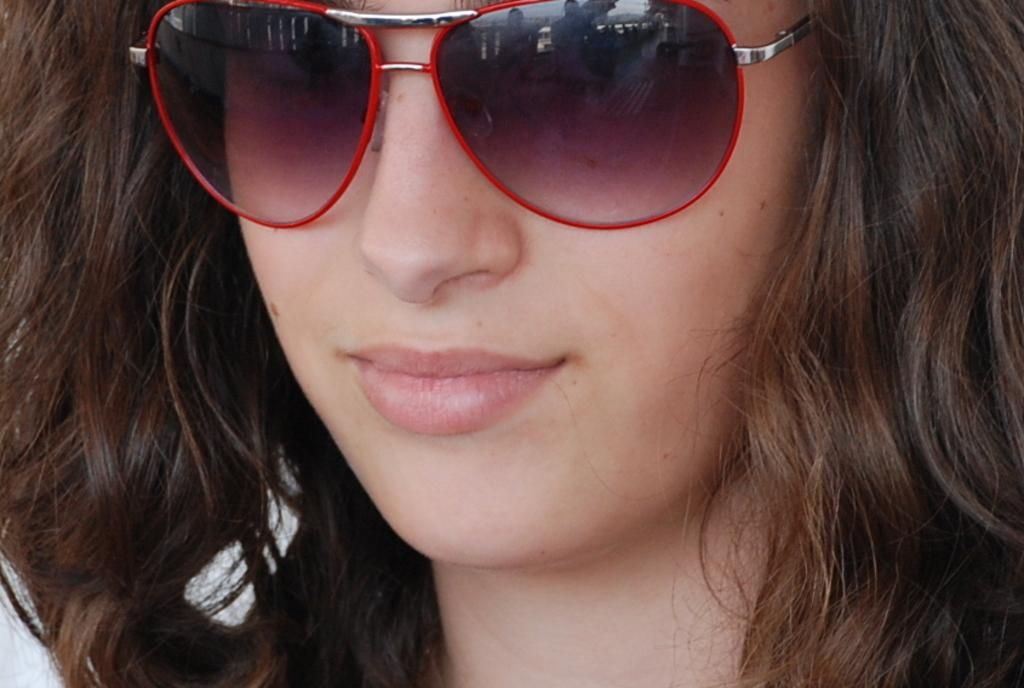Who is the main subject in the image? There is a lady in the image. What is the lady wearing on her face? The lady is wearing goggles. What type of eggnog is the lady holding in the image? There is no eggnog present in the image; the lady is wearing goggles. What type of quartz can be seen in the image? There is no quartz present in the image. 